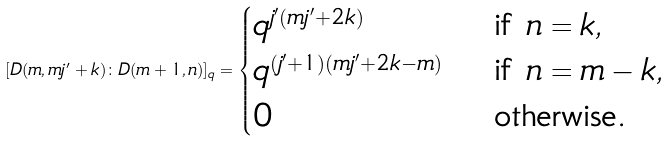<formula> <loc_0><loc_0><loc_500><loc_500>[ D ( m , m j ^ { \prime } + k ) \colon D ( m + 1 , n ) ] _ { q } = \begin{cases} q ^ { j ^ { \prime } ( m j ^ { \prime } + 2 k ) } & \text { if } n = k , \\ q ^ { ( j ^ { \prime } + 1 ) ( m j ^ { \prime } + 2 k - m ) } & \text { if } n = m - k , \\ 0 & \text { otherwise. } \end{cases}</formula> 